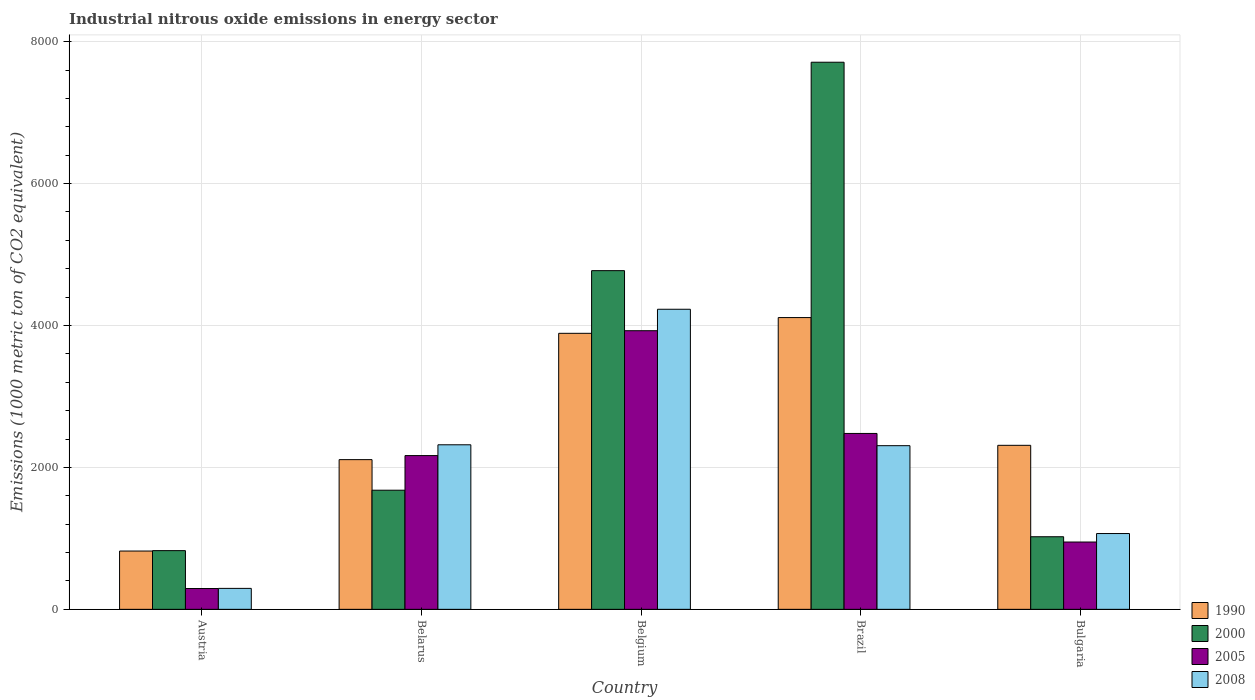In how many cases, is the number of bars for a given country not equal to the number of legend labels?
Offer a very short reply. 0. What is the amount of industrial nitrous oxide emitted in 2008 in Austria?
Give a very brief answer. 295.2. Across all countries, what is the maximum amount of industrial nitrous oxide emitted in 2000?
Offer a very short reply. 7709.7. Across all countries, what is the minimum amount of industrial nitrous oxide emitted in 2000?
Ensure brevity in your answer.  827.2. What is the total amount of industrial nitrous oxide emitted in 2008 in the graph?
Your answer should be compact. 1.02e+04. What is the difference between the amount of industrial nitrous oxide emitted in 2005 in Belarus and that in Bulgaria?
Ensure brevity in your answer.  1218.1. What is the difference between the amount of industrial nitrous oxide emitted in 1990 in Belarus and the amount of industrial nitrous oxide emitted in 2005 in Bulgaria?
Offer a very short reply. 1161. What is the average amount of industrial nitrous oxide emitted in 2008 per country?
Give a very brief answer. 2043.34. What is the difference between the amount of industrial nitrous oxide emitted of/in 2005 and amount of industrial nitrous oxide emitted of/in 2000 in Brazil?
Make the answer very short. -5231.2. What is the ratio of the amount of industrial nitrous oxide emitted in 2005 in Austria to that in Belgium?
Keep it short and to the point. 0.07. Is the amount of industrial nitrous oxide emitted in 2005 in Belarus less than that in Belgium?
Keep it short and to the point. Yes. Is the difference between the amount of industrial nitrous oxide emitted in 2005 in Belgium and Bulgaria greater than the difference between the amount of industrial nitrous oxide emitted in 2000 in Belgium and Bulgaria?
Your answer should be compact. No. What is the difference between the highest and the second highest amount of industrial nitrous oxide emitted in 2000?
Ensure brevity in your answer.  -2937.1. What is the difference between the highest and the lowest amount of industrial nitrous oxide emitted in 2008?
Keep it short and to the point. 3933.4. In how many countries, is the amount of industrial nitrous oxide emitted in 2000 greater than the average amount of industrial nitrous oxide emitted in 2000 taken over all countries?
Your answer should be very brief. 2. Is the sum of the amount of industrial nitrous oxide emitted in 2005 in Belgium and Brazil greater than the maximum amount of industrial nitrous oxide emitted in 2008 across all countries?
Provide a succinct answer. Yes. Is it the case that in every country, the sum of the amount of industrial nitrous oxide emitted in 2005 and amount of industrial nitrous oxide emitted in 1990 is greater than the sum of amount of industrial nitrous oxide emitted in 2008 and amount of industrial nitrous oxide emitted in 2000?
Ensure brevity in your answer.  No. What does the 3rd bar from the left in Brazil represents?
Give a very brief answer. 2005. What does the 2nd bar from the right in Belarus represents?
Offer a terse response. 2005. Is it the case that in every country, the sum of the amount of industrial nitrous oxide emitted in 1990 and amount of industrial nitrous oxide emitted in 2005 is greater than the amount of industrial nitrous oxide emitted in 2000?
Your response must be concise. No. Are all the bars in the graph horizontal?
Offer a terse response. No. Are the values on the major ticks of Y-axis written in scientific E-notation?
Ensure brevity in your answer.  No. Does the graph contain any zero values?
Keep it short and to the point. No. Does the graph contain grids?
Offer a very short reply. Yes. Where does the legend appear in the graph?
Make the answer very short. Bottom right. How many legend labels are there?
Your answer should be very brief. 4. What is the title of the graph?
Provide a short and direct response. Industrial nitrous oxide emissions in energy sector. What is the label or title of the Y-axis?
Offer a very short reply. Emissions (1000 metric ton of CO2 equivalent). What is the Emissions (1000 metric ton of CO2 equivalent) of 1990 in Austria?
Ensure brevity in your answer.  821.5. What is the Emissions (1000 metric ton of CO2 equivalent) in 2000 in Austria?
Your answer should be very brief. 827.2. What is the Emissions (1000 metric ton of CO2 equivalent) in 2005 in Austria?
Your answer should be compact. 293.3. What is the Emissions (1000 metric ton of CO2 equivalent) in 2008 in Austria?
Make the answer very short. 295.2. What is the Emissions (1000 metric ton of CO2 equivalent) in 1990 in Belarus?
Your answer should be compact. 2109.6. What is the Emissions (1000 metric ton of CO2 equivalent) of 2000 in Belarus?
Your answer should be compact. 1678.6. What is the Emissions (1000 metric ton of CO2 equivalent) in 2005 in Belarus?
Offer a terse response. 2166.7. What is the Emissions (1000 metric ton of CO2 equivalent) of 2008 in Belarus?
Your answer should be compact. 2318.7. What is the Emissions (1000 metric ton of CO2 equivalent) of 1990 in Belgium?
Provide a short and direct response. 3889.6. What is the Emissions (1000 metric ton of CO2 equivalent) of 2000 in Belgium?
Make the answer very short. 4772.6. What is the Emissions (1000 metric ton of CO2 equivalent) in 2005 in Belgium?
Your answer should be compact. 3926.3. What is the Emissions (1000 metric ton of CO2 equivalent) in 2008 in Belgium?
Your answer should be compact. 4228.6. What is the Emissions (1000 metric ton of CO2 equivalent) in 1990 in Brazil?
Make the answer very short. 4111.4. What is the Emissions (1000 metric ton of CO2 equivalent) in 2000 in Brazil?
Ensure brevity in your answer.  7709.7. What is the Emissions (1000 metric ton of CO2 equivalent) in 2005 in Brazil?
Offer a terse response. 2478.5. What is the Emissions (1000 metric ton of CO2 equivalent) in 2008 in Brazil?
Ensure brevity in your answer.  2306.2. What is the Emissions (1000 metric ton of CO2 equivalent) of 1990 in Bulgaria?
Offer a very short reply. 2311.2. What is the Emissions (1000 metric ton of CO2 equivalent) of 2000 in Bulgaria?
Provide a succinct answer. 1023. What is the Emissions (1000 metric ton of CO2 equivalent) of 2005 in Bulgaria?
Provide a short and direct response. 948.6. What is the Emissions (1000 metric ton of CO2 equivalent) of 2008 in Bulgaria?
Keep it short and to the point. 1068. Across all countries, what is the maximum Emissions (1000 metric ton of CO2 equivalent) in 1990?
Make the answer very short. 4111.4. Across all countries, what is the maximum Emissions (1000 metric ton of CO2 equivalent) in 2000?
Give a very brief answer. 7709.7. Across all countries, what is the maximum Emissions (1000 metric ton of CO2 equivalent) of 2005?
Offer a terse response. 3926.3. Across all countries, what is the maximum Emissions (1000 metric ton of CO2 equivalent) in 2008?
Your answer should be compact. 4228.6. Across all countries, what is the minimum Emissions (1000 metric ton of CO2 equivalent) in 1990?
Make the answer very short. 821.5. Across all countries, what is the minimum Emissions (1000 metric ton of CO2 equivalent) in 2000?
Provide a succinct answer. 827.2. Across all countries, what is the minimum Emissions (1000 metric ton of CO2 equivalent) of 2005?
Keep it short and to the point. 293.3. Across all countries, what is the minimum Emissions (1000 metric ton of CO2 equivalent) in 2008?
Keep it short and to the point. 295.2. What is the total Emissions (1000 metric ton of CO2 equivalent) in 1990 in the graph?
Provide a short and direct response. 1.32e+04. What is the total Emissions (1000 metric ton of CO2 equivalent) of 2000 in the graph?
Ensure brevity in your answer.  1.60e+04. What is the total Emissions (1000 metric ton of CO2 equivalent) in 2005 in the graph?
Give a very brief answer. 9813.4. What is the total Emissions (1000 metric ton of CO2 equivalent) in 2008 in the graph?
Your response must be concise. 1.02e+04. What is the difference between the Emissions (1000 metric ton of CO2 equivalent) in 1990 in Austria and that in Belarus?
Provide a succinct answer. -1288.1. What is the difference between the Emissions (1000 metric ton of CO2 equivalent) of 2000 in Austria and that in Belarus?
Offer a very short reply. -851.4. What is the difference between the Emissions (1000 metric ton of CO2 equivalent) of 2005 in Austria and that in Belarus?
Give a very brief answer. -1873.4. What is the difference between the Emissions (1000 metric ton of CO2 equivalent) in 2008 in Austria and that in Belarus?
Your response must be concise. -2023.5. What is the difference between the Emissions (1000 metric ton of CO2 equivalent) of 1990 in Austria and that in Belgium?
Your answer should be very brief. -3068.1. What is the difference between the Emissions (1000 metric ton of CO2 equivalent) in 2000 in Austria and that in Belgium?
Your answer should be very brief. -3945.4. What is the difference between the Emissions (1000 metric ton of CO2 equivalent) in 2005 in Austria and that in Belgium?
Your response must be concise. -3633. What is the difference between the Emissions (1000 metric ton of CO2 equivalent) in 2008 in Austria and that in Belgium?
Provide a succinct answer. -3933.4. What is the difference between the Emissions (1000 metric ton of CO2 equivalent) of 1990 in Austria and that in Brazil?
Your answer should be compact. -3289.9. What is the difference between the Emissions (1000 metric ton of CO2 equivalent) of 2000 in Austria and that in Brazil?
Your answer should be compact. -6882.5. What is the difference between the Emissions (1000 metric ton of CO2 equivalent) in 2005 in Austria and that in Brazil?
Your answer should be very brief. -2185.2. What is the difference between the Emissions (1000 metric ton of CO2 equivalent) in 2008 in Austria and that in Brazil?
Ensure brevity in your answer.  -2011. What is the difference between the Emissions (1000 metric ton of CO2 equivalent) of 1990 in Austria and that in Bulgaria?
Your answer should be compact. -1489.7. What is the difference between the Emissions (1000 metric ton of CO2 equivalent) in 2000 in Austria and that in Bulgaria?
Your response must be concise. -195.8. What is the difference between the Emissions (1000 metric ton of CO2 equivalent) of 2005 in Austria and that in Bulgaria?
Ensure brevity in your answer.  -655.3. What is the difference between the Emissions (1000 metric ton of CO2 equivalent) of 2008 in Austria and that in Bulgaria?
Offer a terse response. -772.8. What is the difference between the Emissions (1000 metric ton of CO2 equivalent) in 1990 in Belarus and that in Belgium?
Your answer should be very brief. -1780. What is the difference between the Emissions (1000 metric ton of CO2 equivalent) of 2000 in Belarus and that in Belgium?
Keep it short and to the point. -3094. What is the difference between the Emissions (1000 metric ton of CO2 equivalent) of 2005 in Belarus and that in Belgium?
Ensure brevity in your answer.  -1759.6. What is the difference between the Emissions (1000 metric ton of CO2 equivalent) of 2008 in Belarus and that in Belgium?
Offer a very short reply. -1909.9. What is the difference between the Emissions (1000 metric ton of CO2 equivalent) in 1990 in Belarus and that in Brazil?
Your response must be concise. -2001.8. What is the difference between the Emissions (1000 metric ton of CO2 equivalent) of 2000 in Belarus and that in Brazil?
Your answer should be very brief. -6031.1. What is the difference between the Emissions (1000 metric ton of CO2 equivalent) in 2005 in Belarus and that in Brazil?
Your response must be concise. -311.8. What is the difference between the Emissions (1000 metric ton of CO2 equivalent) of 2008 in Belarus and that in Brazil?
Ensure brevity in your answer.  12.5. What is the difference between the Emissions (1000 metric ton of CO2 equivalent) in 1990 in Belarus and that in Bulgaria?
Your answer should be compact. -201.6. What is the difference between the Emissions (1000 metric ton of CO2 equivalent) in 2000 in Belarus and that in Bulgaria?
Ensure brevity in your answer.  655.6. What is the difference between the Emissions (1000 metric ton of CO2 equivalent) of 2005 in Belarus and that in Bulgaria?
Ensure brevity in your answer.  1218.1. What is the difference between the Emissions (1000 metric ton of CO2 equivalent) of 2008 in Belarus and that in Bulgaria?
Offer a terse response. 1250.7. What is the difference between the Emissions (1000 metric ton of CO2 equivalent) in 1990 in Belgium and that in Brazil?
Your response must be concise. -221.8. What is the difference between the Emissions (1000 metric ton of CO2 equivalent) in 2000 in Belgium and that in Brazil?
Offer a very short reply. -2937.1. What is the difference between the Emissions (1000 metric ton of CO2 equivalent) of 2005 in Belgium and that in Brazil?
Your answer should be very brief. 1447.8. What is the difference between the Emissions (1000 metric ton of CO2 equivalent) in 2008 in Belgium and that in Brazil?
Offer a very short reply. 1922.4. What is the difference between the Emissions (1000 metric ton of CO2 equivalent) in 1990 in Belgium and that in Bulgaria?
Offer a terse response. 1578.4. What is the difference between the Emissions (1000 metric ton of CO2 equivalent) of 2000 in Belgium and that in Bulgaria?
Offer a terse response. 3749.6. What is the difference between the Emissions (1000 metric ton of CO2 equivalent) in 2005 in Belgium and that in Bulgaria?
Offer a terse response. 2977.7. What is the difference between the Emissions (1000 metric ton of CO2 equivalent) of 2008 in Belgium and that in Bulgaria?
Your response must be concise. 3160.6. What is the difference between the Emissions (1000 metric ton of CO2 equivalent) of 1990 in Brazil and that in Bulgaria?
Make the answer very short. 1800.2. What is the difference between the Emissions (1000 metric ton of CO2 equivalent) in 2000 in Brazil and that in Bulgaria?
Offer a terse response. 6686.7. What is the difference between the Emissions (1000 metric ton of CO2 equivalent) of 2005 in Brazil and that in Bulgaria?
Your answer should be compact. 1529.9. What is the difference between the Emissions (1000 metric ton of CO2 equivalent) in 2008 in Brazil and that in Bulgaria?
Keep it short and to the point. 1238.2. What is the difference between the Emissions (1000 metric ton of CO2 equivalent) of 1990 in Austria and the Emissions (1000 metric ton of CO2 equivalent) of 2000 in Belarus?
Offer a very short reply. -857.1. What is the difference between the Emissions (1000 metric ton of CO2 equivalent) in 1990 in Austria and the Emissions (1000 metric ton of CO2 equivalent) in 2005 in Belarus?
Offer a very short reply. -1345.2. What is the difference between the Emissions (1000 metric ton of CO2 equivalent) of 1990 in Austria and the Emissions (1000 metric ton of CO2 equivalent) of 2008 in Belarus?
Your answer should be compact. -1497.2. What is the difference between the Emissions (1000 metric ton of CO2 equivalent) in 2000 in Austria and the Emissions (1000 metric ton of CO2 equivalent) in 2005 in Belarus?
Ensure brevity in your answer.  -1339.5. What is the difference between the Emissions (1000 metric ton of CO2 equivalent) of 2000 in Austria and the Emissions (1000 metric ton of CO2 equivalent) of 2008 in Belarus?
Make the answer very short. -1491.5. What is the difference between the Emissions (1000 metric ton of CO2 equivalent) of 2005 in Austria and the Emissions (1000 metric ton of CO2 equivalent) of 2008 in Belarus?
Your answer should be compact. -2025.4. What is the difference between the Emissions (1000 metric ton of CO2 equivalent) of 1990 in Austria and the Emissions (1000 metric ton of CO2 equivalent) of 2000 in Belgium?
Give a very brief answer. -3951.1. What is the difference between the Emissions (1000 metric ton of CO2 equivalent) in 1990 in Austria and the Emissions (1000 metric ton of CO2 equivalent) in 2005 in Belgium?
Your response must be concise. -3104.8. What is the difference between the Emissions (1000 metric ton of CO2 equivalent) in 1990 in Austria and the Emissions (1000 metric ton of CO2 equivalent) in 2008 in Belgium?
Your response must be concise. -3407.1. What is the difference between the Emissions (1000 metric ton of CO2 equivalent) of 2000 in Austria and the Emissions (1000 metric ton of CO2 equivalent) of 2005 in Belgium?
Keep it short and to the point. -3099.1. What is the difference between the Emissions (1000 metric ton of CO2 equivalent) of 2000 in Austria and the Emissions (1000 metric ton of CO2 equivalent) of 2008 in Belgium?
Offer a terse response. -3401.4. What is the difference between the Emissions (1000 metric ton of CO2 equivalent) in 2005 in Austria and the Emissions (1000 metric ton of CO2 equivalent) in 2008 in Belgium?
Offer a terse response. -3935.3. What is the difference between the Emissions (1000 metric ton of CO2 equivalent) in 1990 in Austria and the Emissions (1000 metric ton of CO2 equivalent) in 2000 in Brazil?
Your response must be concise. -6888.2. What is the difference between the Emissions (1000 metric ton of CO2 equivalent) in 1990 in Austria and the Emissions (1000 metric ton of CO2 equivalent) in 2005 in Brazil?
Provide a short and direct response. -1657. What is the difference between the Emissions (1000 metric ton of CO2 equivalent) in 1990 in Austria and the Emissions (1000 metric ton of CO2 equivalent) in 2008 in Brazil?
Give a very brief answer. -1484.7. What is the difference between the Emissions (1000 metric ton of CO2 equivalent) of 2000 in Austria and the Emissions (1000 metric ton of CO2 equivalent) of 2005 in Brazil?
Your answer should be compact. -1651.3. What is the difference between the Emissions (1000 metric ton of CO2 equivalent) in 2000 in Austria and the Emissions (1000 metric ton of CO2 equivalent) in 2008 in Brazil?
Offer a very short reply. -1479. What is the difference between the Emissions (1000 metric ton of CO2 equivalent) of 2005 in Austria and the Emissions (1000 metric ton of CO2 equivalent) of 2008 in Brazil?
Give a very brief answer. -2012.9. What is the difference between the Emissions (1000 metric ton of CO2 equivalent) of 1990 in Austria and the Emissions (1000 metric ton of CO2 equivalent) of 2000 in Bulgaria?
Ensure brevity in your answer.  -201.5. What is the difference between the Emissions (1000 metric ton of CO2 equivalent) in 1990 in Austria and the Emissions (1000 metric ton of CO2 equivalent) in 2005 in Bulgaria?
Your answer should be very brief. -127.1. What is the difference between the Emissions (1000 metric ton of CO2 equivalent) of 1990 in Austria and the Emissions (1000 metric ton of CO2 equivalent) of 2008 in Bulgaria?
Your answer should be very brief. -246.5. What is the difference between the Emissions (1000 metric ton of CO2 equivalent) in 2000 in Austria and the Emissions (1000 metric ton of CO2 equivalent) in 2005 in Bulgaria?
Provide a succinct answer. -121.4. What is the difference between the Emissions (1000 metric ton of CO2 equivalent) of 2000 in Austria and the Emissions (1000 metric ton of CO2 equivalent) of 2008 in Bulgaria?
Make the answer very short. -240.8. What is the difference between the Emissions (1000 metric ton of CO2 equivalent) of 2005 in Austria and the Emissions (1000 metric ton of CO2 equivalent) of 2008 in Bulgaria?
Make the answer very short. -774.7. What is the difference between the Emissions (1000 metric ton of CO2 equivalent) of 1990 in Belarus and the Emissions (1000 metric ton of CO2 equivalent) of 2000 in Belgium?
Give a very brief answer. -2663. What is the difference between the Emissions (1000 metric ton of CO2 equivalent) in 1990 in Belarus and the Emissions (1000 metric ton of CO2 equivalent) in 2005 in Belgium?
Offer a terse response. -1816.7. What is the difference between the Emissions (1000 metric ton of CO2 equivalent) in 1990 in Belarus and the Emissions (1000 metric ton of CO2 equivalent) in 2008 in Belgium?
Provide a short and direct response. -2119. What is the difference between the Emissions (1000 metric ton of CO2 equivalent) in 2000 in Belarus and the Emissions (1000 metric ton of CO2 equivalent) in 2005 in Belgium?
Your response must be concise. -2247.7. What is the difference between the Emissions (1000 metric ton of CO2 equivalent) in 2000 in Belarus and the Emissions (1000 metric ton of CO2 equivalent) in 2008 in Belgium?
Offer a terse response. -2550. What is the difference between the Emissions (1000 metric ton of CO2 equivalent) of 2005 in Belarus and the Emissions (1000 metric ton of CO2 equivalent) of 2008 in Belgium?
Make the answer very short. -2061.9. What is the difference between the Emissions (1000 metric ton of CO2 equivalent) in 1990 in Belarus and the Emissions (1000 metric ton of CO2 equivalent) in 2000 in Brazil?
Give a very brief answer. -5600.1. What is the difference between the Emissions (1000 metric ton of CO2 equivalent) of 1990 in Belarus and the Emissions (1000 metric ton of CO2 equivalent) of 2005 in Brazil?
Give a very brief answer. -368.9. What is the difference between the Emissions (1000 metric ton of CO2 equivalent) in 1990 in Belarus and the Emissions (1000 metric ton of CO2 equivalent) in 2008 in Brazil?
Your answer should be compact. -196.6. What is the difference between the Emissions (1000 metric ton of CO2 equivalent) of 2000 in Belarus and the Emissions (1000 metric ton of CO2 equivalent) of 2005 in Brazil?
Your answer should be compact. -799.9. What is the difference between the Emissions (1000 metric ton of CO2 equivalent) in 2000 in Belarus and the Emissions (1000 metric ton of CO2 equivalent) in 2008 in Brazil?
Your response must be concise. -627.6. What is the difference between the Emissions (1000 metric ton of CO2 equivalent) in 2005 in Belarus and the Emissions (1000 metric ton of CO2 equivalent) in 2008 in Brazil?
Your answer should be very brief. -139.5. What is the difference between the Emissions (1000 metric ton of CO2 equivalent) in 1990 in Belarus and the Emissions (1000 metric ton of CO2 equivalent) in 2000 in Bulgaria?
Your answer should be compact. 1086.6. What is the difference between the Emissions (1000 metric ton of CO2 equivalent) in 1990 in Belarus and the Emissions (1000 metric ton of CO2 equivalent) in 2005 in Bulgaria?
Your answer should be compact. 1161. What is the difference between the Emissions (1000 metric ton of CO2 equivalent) of 1990 in Belarus and the Emissions (1000 metric ton of CO2 equivalent) of 2008 in Bulgaria?
Give a very brief answer. 1041.6. What is the difference between the Emissions (1000 metric ton of CO2 equivalent) of 2000 in Belarus and the Emissions (1000 metric ton of CO2 equivalent) of 2005 in Bulgaria?
Provide a succinct answer. 730. What is the difference between the Emissions (1000 metric ton of CO2 equivalent) of 2000 in Belarus and the Emissions (1000 metric ton of CO2 equivalent) of 2008 in Bulgaria?
Make the answer very short. 610.6. What is the difference between the Emissions (1000 metric ton of CO2 equivalent) of 2005 in Belarus and the Emissions (1000 metric ton of CO2 equivalent) of 2008 in Bulgaria?
Provide a short and direct response. 1098.7. What is the difference between the Emissions (1000 metric ton of CO2 equivalent) in 1990 in Belgium and the Emissions (1000 metric ton of CO2 equivalent) in 2000 in Brazil?
Give a very brief answer. -3820.1. What is the difference between the Emissions (1000 metric ton of CO2 equivalent) in 1990 in Belgium and the Emissions (1000 metric ton of CO2 equivalent) in 2005 in Brazil?
Your response must be concise. 1411.1. What is the difference between the Emissions (1000 metric ton of CO2 equivalent) in 1990 in Belgium and the Emissions (1000 metric ton of CO2 equivalent) in 2008 in Brazil?
Provide a short and direct response. 1583.4. What is the difference between the Emissions (1000 metric ton of CO2 equivalent) of 2000 in Belgium and the Emissions (1000 metric ton of CO2 equivalent) of 2005 in Brazil?
Keep it short and to the point. 2294.1. What is the difference between the Emissions (1000 metric ton of CO2 equivalent) in 2000 in Belgium and the Emissions (1000 metric ton of CO2 equivalent) in 2008 in Brazil?
Your response must be concise. 2466.4. What is the difference between the Emissions (1000 metric ton of CO2 equivalent) of 2005 in Belgium and the Emissions (1000 metric ton of CO2 equivalent) of 2008 in Brazil?
Your answer should be compact. 1620.1. What is the difference between the Emissions (1000 metric ton of CO2 equivalent) in 1990 in Belgium and the Emissions (1000 metric ton of CO2 equivalent) in 2000 in Bulgaria?
Your answer should be compact. 2866.6. What is the difference between the Emissions (1000 metric ton of CO2 equivalent) in 1990 in Belgium and the Emissions (1000 metric ton of CO2 equivalent) in 2005 in Bulgaria?
Keep it short and to the point. 2941. What is the difference between the Emissions (1000 metric ton of CO2 equivalent) in 1990 in Belgium and the Emissions (1000 metric ton of CO2 equivalent) in 2008 in Bulgaria?
Offer a very short reply. 2821.6. What is the difference between the Emissions (1000 metric ton of CO2 equivalent) in 2000 in Belgium and the Emissions (1000 metric ton of CO2 equivalent) in 2005 in Bulgaria?
Provide a succinct answer. 3824. What is the difference between the Emissions (1000 metric ton of CO2 equivalent) of 2000 in Belgium and the Emissions (1000 metric ton of CO2 equivalent) of 2008 in Bulgaria?
Make the answer very short. 3704.6. What is the difference between the Emissions (1000 metric ton of CO2 equivalent) in 2005 in Belgium and the Emissions (1000 metric ton of CO2 equivalent) in 2008 in Bulgaria?
Make the answer very short. 2858.3. What is the difference between the Emissions (1000 metric ton of CO2 equivalent) in 1990 in Brazil and the Emissions (1000 metric ton of CO2 equivalent) in 2000 in Bulgaria?
Your answer should be compact. 3088.4. What is the difference between the Emissions (1000 metric ton of CO2 equivalent) of 1990 in Brazil and the Emissions (1000 metric ton of CO2 equivalent) of 2005 in Bulgaria?
Provide a short and direct response. 3162.8. What is the difference between the Emissions (1000 metric ton of CO2 equivalent) of 1990 in Brazil and the Emissions (1000 metric ton of CO2 equivalent) of 2008 in Bulgaria?
Provide a short and direct response. 3043.4. What is the difference between the Emissions (1000 metric ton of CO2 equivalent) of 2000 in Brazil and the Emissions (1000 metric ton of CO2 equivalent) of 2005 in Bulgaria?
Make the answer very short. 6761.1. What is the difference between the Emissions (1000 metric ton of CO2 equivalent) of 2000 in Brazil and the Emissions (1000 metric ton of CO2 equivalent) of 2008 in Bulgaria?
Provide a short and direct response. 6641.7. What is the difference between the Emissions (1000 metric ton of CO2 equivalent) in 2005 in Brazil and the Emissions (1000 metric ton of CO2 equivalent) in 2008 in Bulgaria?
Offer a terse response. 1410.5. What is the average Emissions (1000 metric ton of CO2 equivalent) in 1990 per country?
Give a very brief answer. 2648.66. What is the average Emissions (1000 metric ton of CO2 equivalent) of 2000 per country?
Your answer should be compact. 3202.22. What is the average Emissions (1000 metric ton of CO2 equivalent) in 2005 per country?
Offer a very short reply. 1962.68. What is the average Emissions (1000 metric ton of CO2 equivalent) of 2008 per country?
Keep it short and to the point. 2043.34. What is the difference between the Emissions (1000 metric ton of CO2 equivalent) in 1990 and Emissions (1000 metric ton of CO2 equivalent) in 2000 in Austria?
Ensure brevity in your answer.  -5.7. What is the difference between the Emissions (1000 metric ton of CO2 equivalent) of 1990 and Emissions (1000 metric ton of CO2 equivalent) of 2005 in Austria?
Keep it short and to the point. 528.2. What is the difference between the Emissions (1000 metric ton of CO2 equivalent) of 1990 and Emissions (1000 metric ton of CO2 equivalent) of 2008 in Austria?
Provide a succinct answer. 526.3. What is the difference between the Emissions (1000 metric ton of CO2 equivalent) of 2000 and Emissions (1000 metric ton of CO2 equivalent) of 2005 in Austria?
Keep it short and to the point. 533.9. What is the difference between the Emissions (1000 metric ton of CO2 equivalent) of 2000 and Emissions (1000 metric ton of CO2 equivalent) of 2008 in Austria?
Keep it short and to the point. 532. What is the difference between the Emissions (1000 metric ton of CO2 equivalent) in 2005 and Emissions (1000 metric ton of CO2 equivalent) in 2008 in Austria?
Provide a succinct answer. -1.9. What is the difference between the Emissions (1000 metric ton of CO2 equivalent) of 1990 and Emissions (1000 metric ton of CO2 equivalent) of 2000 in Belarus?
Offer a terse response. 431. What is the difference between the Emissions (1000 metric ton of CO2 equivalent) of 1990 and Emissions (1000 metric ton of CO2 equivalent) of 2005 in Belarus?
Your answer should be compact. -57.1. What is the difference between the Emissions (1000 metric ton of CO2 equivalent) of 1990 and Emissions (1000 metric ton of CO2 equivalent) of 2008 in Belarus?
Your answer should be very brief. -209.1. What is the difference between the Emissions (1000 metric ton of CO2 equivalent) of 2000 and Emissions (1000 metric ton of CO2 equivalent) of 2005 in Belarus?
Provide a short and direct response. -488.1. What is the difference between the Emissions (1000 metric ton of CO2 equivalent) in 2000 and Emissions (1000 metric ton of CO2 equivalent) in 2008 in Belarus?
Offer a very short reply. -640.1. What is the difference between the Emissions (1000 metric ton of CO2 equivalent) in 2005 and Emissions (1000 metric ton of CO2 equivalent) in 2008 in Belarus?
Offer a very short reply. -152. What is the difference between the Emissions (1000 metric ton of CO2 equivalent) in 1990 and Emissions (1000 metric ton of CO2 equivalent) in 2000 in Belgium?
Keep it short and to the point. -883. What is the difference between the Emissions (1000 metric ton of CO2 equivalent) of 1990 and Emissions (1000 metric ton of CO2 equivalent) of 2005 in Belgium?
Your response must be concise. -36.7. What is the difference between the Emissions (1000 metric ton of CO2 equivalent) in 1990 and Emissions (1000 metric ton of CO2 equivalent) in 2008 in Belgium?
Make the answer very short. -339. What is the difference between the Emissions (1000 metric ton of CO2 equivalent) in 2000 and Emissions (1000 metric ton of CO2 equivalent) in 2005 in Belgium?
Offer a terse response. 846.3. What is the difference between the Emissions (1000 metric ton of CO2 equivalent) in 2000 and Emissions (1000 metric ton of CO2 equivalent) in 2008 in Belgium?
Give a very brief answer. 544. What is the difference between the Emissions (1000 metric ton of CO2 equivalent) in 2005 and Emissions (1000 metric ton of CO2 equivalent) in 2008 in Belgium?
Give a very brief answer. -302.3. What is the difference between the Emissions (1000 metric ton of CO2 equivalent) in 1990 and Emissions (1000 metric ton of CO2 equivalent) in 2000 in Brazil?
Make the answer very short. -3598.3. What is the difference between the Emissions (1000 metric ton of CO2 equivalent) of 1990 and Emissions (1000 metric ton of CO2 equivalent) of 2005 in Brazil?
Your answer should be compact. 1632.9. What is the difference between the Emissions (1000 metric ton of CO2 equivalent) in 1990 and Emissions (1000 metric ton of CO2 equivalent) in 2008 in Brazil?
Provide a succinct answer. 1805.2. What is the difference between the Emissions (1000 metric ton of CO2 equivalent) of 2000 and Emissions (1000 metric ton of CO2 equivalent) of 2005 in Brazil?
Your answer should be compact. 5231.2. What is the difference between the Emissions (1000 metric ton of CO2 equivalent) in 2000 and Emissions (1000 metric ton of CO2 equivalent) in 2008 in Brazil?
Keep it short and to the point. 5403.5. What is the difference between the Emissions (1000 metric ton of CO2 equivalent) in 2005 and Emissions (1000 metric ton of CO2 equivalent) in 2008 in Brazil?
Your answer should be very brief. 172.3. What is the difference between the Emissions (1000 metric ton of CO2 equivalent) in 1990 and Emissions (1000 metric ton of CO2 equivalent) in 2000 in Bulgaria?
Give a very brief answer. 1288.2. What is the difference between the Emissions (1000 metric ton of CO2 equivalent) of 1990 and Emissions (1000 metric ton of CO2 equivalent) of 2005 in Bulgaria?
Your answer should be very brief. 1362.6. What is the difference between the Emissions (1000 metric ton of CO2 equivalent) in 1990 and Emissions (1000 metric ton of CO2 equivalent) in 2008 in Bulgaria?
Give a very brief answer. 1243.2. What is the difference between the Emissions (1000 metric ton of CO2 equivalent) in 2000 and Emissions (1000 metric ton of CO2 equivalent) in 2005 in Bulgaria?
Your answer should be compact. 74.4. What is the difference between the Emissions (1000 metric ton of CO2 equivalent) of 2000 and Emissions (1000 metric ton of CO2 equivalent) of 2008 in Bulgaria?
Keep it short and to the point. -45. What is the difference between the Emissions (1000 metric ton of CO2 equivalent) in 2005 and Emissions (1000 metric ton of CO2 equivalent) in 2008 in Bulgaria?
Your answer should be compact. -119.4. What is the ratio of the Emissions (1000 metric ton of CO2 equivalent) in 1990 in Austria to that in Belarus?
Your answer should be compact. 0.39. What is the ratio of the Emissions (1000 metric ton of CO2 equivalent) of 2000 in Austria to that in Belarus?
Ensure brevity in your answer.  0.49. What is the ratio of the Emissions (1000 metric ton of CO2 equivalent) in 2005 in Austria to that in Belarus?
Provide a succinct answer. 0.14. What is the ratio of the Emissions (1000 metric ton of CO2 equivalent) in 2008 in Austria to that in Belarus?
Your answer should be compact. 0.13. What is the ratio of the Emissions (1000 metric ton of CO2 equivalent) of 1990 in Austria to that in Belgium?
Your answer should be very brief. 0.21. What is the ratio of the Emissions (1000 metric ton of CO2 equivalent) in 2000 in Austria to that in Belgium?
Offer a terse response. 0.17. What is the ratio of the Emissions (1000 metric ton of CO2 equivalent) of 2005 in Austria to that in Belgium?
Ensure brevity in your answer.  0.07. What is the ratio of the Emissions (1000 metric ton of CO2 equivalent) of 2008 in Austria to that in Belgium?
Ensure brevity in your answer.  0.07. What is the ratio of the Emissions (1000 metric ton of CO2 equivalent) of 1990 in Austria to that in Brazil?
Keep it short and to the point. 0.2. What is the ratio of the Emissions (1000 metric ton of CO2 equivalent) in 2000 in Austria to that in Brazil?
Your answer should be very brief. 0.11. What is the ratio of the Emissions (1000 metric ton of CO2 equivalent) of 2005 in Austria to that in Brazil?
Give a very brief answer. 0.12. What is the ratio of the Emissions (1000 metric ton of CO2 equivalent) of 2008 in Austria to that in Brazil?
Ensure brevity in your answer.  0.13. What is the ratio of the Emissions (1000 metric ton of CO2 equivalent) in 1990 in Austria to that in Bulgaria?
Your answer should be compact. 0.36. What is the ratio of the Emissions (1000 metric ton of CO2 equivalent) of 2000 in Austria to that in Bulgaria?
Give a very brief answer. 0.81. What is the ratio of the Emissions (1000 metric ton of CO2 equivalent) of 2005 in Austria to that in Bulgaria?
Provide a short and direct response. 0.31. What is the ratio of the Emissions (1000 metric ton of CO2 equivalent) of 2008 in Austria to that in Bulgaria?
Offer a terse response. 0.28. What is the ratio of the Emissions (1000 metric ton of CO2 equivalent) of 1990 in Belarus to that in Belgium?
Provide a succinct answer. 0.54. What is the ratio of the Emissions (1000 metric ton of CO2 equivalent) of 2000 in Belarus to that in Belgium?
Keep it short and to the point. 0.35. What is the ratio of the Emissions (1000 metric ton of CO2 equivalent) in 2005 in Belarus to that in Belgium?
Offer a terse response. 0.55. What is the ratio of the Emissions (1000 metric ton of CO2 equivalent) of 2008 in Belarus to that in Belgium?
Your answer should be very brief. 0.55. What is the ratio of the Emissions (1000 metric ton of CO2 equivalent) of 1990 in Belarus to that in Brazil?
Provide a succinct answer. 0.51. What is the ratio of the Emissions (1000 metric ton of CO2 equivalent) in 2000 in Belarus to that in Brazil?
Your answer should be very brief. 0.22. What is the ratio of the Emissions (1000 metric ton of CO2 equivalent) in 2005 in Belarus to that in Brazil?
Ensure brevity in your answer.  0.87. What is the ratio of the Emissions (1000 metric ton of CO2 equivalent) of 2008 in Belarus to that in Brazil?
Keep it short and to the point. 1.01. What is the ratio of the Emissions (1000 metric ton of CO2 equivalent) in 1990 in Belarus to that in Bulgaria?
Provide a short and direct response. 0.91. What is the ratio of the Emissions (1000 metric ton of CO2 equivalent) in 2000 in Belarus to that in Bulgaria?
Offer a terse response. 1.64. What is the ratio of the Emissions (1000 metric ton of CO2 equivalent) in 2005 in Belarus to that in Bulgaria?
Your answer should be compact. 2.28. What is the ratio of the Emissions (1000 metric ton of CO2 equivalent) in 2008 in Belarus to that in Bulgaria?
Offer a very short reply. 2.17. What is the ratio of the Emissions (1000 metric ton of CO2 equivalent) of 1990 in Belgium to that in Brazil?
Offer a terse response. 0.95. What is the ratio of the Emissions (1000 metric ton of CO2 equivalent) in 2000 in Belgium to that in Brazil?
Ensure brevity in your answer.  0.62. What is the ratio of the Emissions (1000 metric ton of CO2 equivalent) of 2005 in Belgium to that in Brazil?
Give a very brief answer. 1.58. What is the ratio of the Emissions (1000 metric ton of CO2 equivalent) of 2008 in Belgium to that in Brazil?
Your answer should be compact. 1.83. What is the ratio of the Emissions (1000 metric ton of CO2 equivalent) in 1990 in Belgium to that in Bulgaria?
Make the answer very short. 1.68. What is the ratio of the Emissions (1000 metric ton of CO2 equivalent) in 2000 in Belgium to that in Bulgaria?
Offer a terse response. 4.67. What is the ratio of the Emissions (1000 metric ton of CO2 equivalent) of 2005 in Belgium to that in Bulgaria?
Ensure brevity in your answer.  4.14. What is the ratio of the Emissions (1000 metric ton of CO2 equivalent) of 2008 in Belgium to that in Bulgaria?
Provide a short and direct response. 3.96. What is the ratio of the Emissions (1000 metric ton of CO2 equivalent) of 1990 in Brazil to that in Bulgaria?
Make the answer very short. 1.78. What is the ratio of the Emissions (1000 metric ton of CO2 equivalent) of 2000 in Brazil to that in Bulgaria?
Give a very brief answer. 7.54. What is the ratio of the Emissions (1000 metric ton of CO2 equivalent) in 2005 in Brazil to that in Bulgaria?
Give a very brief answer. 2.61. What is the ratio of the Emissions (1000 metric ton of CO2 equivalent) of 2008 in Brazil to that in Bulgaria?
Offer a very short reply. 2.16. What is the difference between the highest and the second highest Emissions (1000 metric ton of CO2 equivalent) in 1990?
Make the answer very short. 221.8. What is the difference between the highest and the second highest Emissions (1000 metric ton of CO2 equivalent) in 2000?
Your response must be concise. 2937.1. What is the difference between the highest and the second highest Emissions (1000 metric ton of CO2 equivalent) in 2005?
Provide a succinct answer. 1447.8. What is the difference between the highest and the second highest Emissions (1000 metric ton of CO2 equivalent) in 2008?
Keep it short and to the point. 1909.9. What is the difference between the highest and the lowest Emissions (1000 metric ton of CO2 equivalent) in 1990?
Your answer should be very brief. 3289.9. What is the difference between the highest and the lowest Emissions (1000 metric ton of CO2 equivalent) of 2000?
Give a very brief answer. 6882.5. What is the difference between the highest and the lowest Emissions (1000 metric ton of CO2 equivalent) of 2005?
Your answer should be very brief. 3633. What is the difference between the highest and the lowest Emissions (1000 metric ton of CO2 equivalent) of 2008?
Keep it short and to the point. 3933.4. 